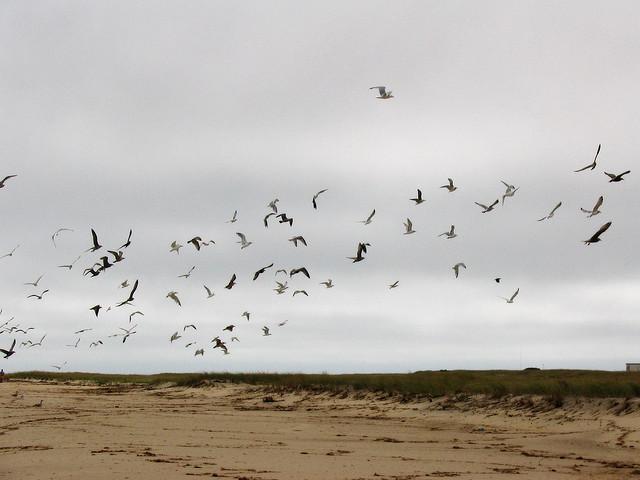How many benches are there?
Give a very brief answer. 0. 